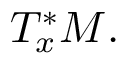<formula> <loc_0><loc_0><loc_500><loc_500>T _ { x } ^ { * } M .</formula> 